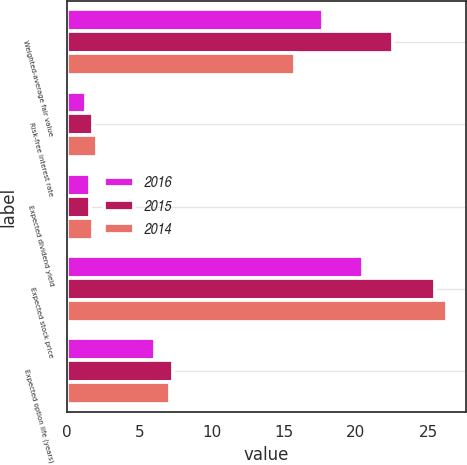<chart> <loc_0><loc_0><loc_500><loc_500><stacked_bar_chart><ecel><fcel>Weighted-average fair value<fcel>Risk-free interest rate<fcel>Expected dividend yield<fcel>Expected stock price<fcel>Expected option life (years)<nl><fcel>2016<fcel>17.73<fcel>1.3<fcel>1.6<fcel>20.5<fcel>6.1<nl><fcel>2015<fcel>22.55<fcel>1.8<fcel>1.6<fcel>25.5<fcel>7.3<nl><fcel>2014<fcel>15.8<fcel>2.1<fcel>1.8<fcel>26.3<fcel>7.1<nl></chart> 